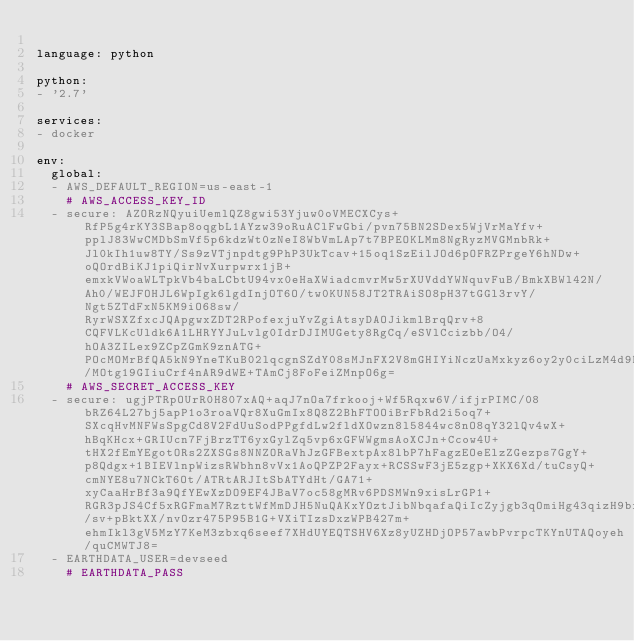Convert code to text. <code><loc_0><loc_0><loc_500><loc_500><_YAML_>
language: python

python:
- '2.7'

services:
- docker

env:
  global:
  - AWS_DEFAULT_REGION=us-east-1
    # AWS_ACCESS_KEY_ID
  - secure: AZORzNQyuiUemlQZ8gwi53Yjuw0oVMECXCys+RfP5g4rKY3SBap8oqgbL1AYzw39oRuAClFwGbi/pvn75BN2SDex5WjVrMaYfv+pplJ83WwCMDbSmVf5p6kdzWt0zNeI8WbVmLAp7t7BPEOKLMm8NgRyzMVGMnbRk+Jl0kIh1uw8TY/Ss9zVTjnpdtg9PhP3UkTcav+15oq1SzEilJOd6pOFRZPrgeY6hNDw+oQOrdBiKJ1piQirNvXurpwrx1jB+emxkVWoaWLTpkVb4baLCbtU94vx0eHaXWiadcmvrMw5rXUVddYWNquvFuB/BmkXBWl42N/Ah0/WEJFOHJL6WpIgk6lgdInjOT6O/tw0KUN58JT2TRAiSO8pH37tGGl3rvY/Ngt5ZTdFxN5KM9iO68sw/RyrWSXZfxcJQApgwxZDT2RPofexjuYvZgiAtsyDAOJikmlBrqQrv+8CQFVLKcUldk6A1LHRYYJuLvlg0IdrDJIMUGety8RgCq/eSVlCcizbb/O4/hOA3ZILex9ZCpZGmK9znATG+POcMOMrBfQA5kN9YneTKuB02lqcgnSZdY08sMJnFX2V8mGHIYiNczUaMxkyz6oy2y0ciLzM4d9BQjd8SFmJNHmXTSDc4AU4vW/MOtg19GIiuCrf4nAR9dWE+TAmCj8FoFeiZMnpO6g=
    # AWS_SECRET_ACCESS_KEY
  - secure: ugjPTRpOUrR0H807xAQ+aqJ7nOa7frkooj+Wf5Rqxw6V/ifjrPIMC/08bRZ64L27bj5apP1o3roaVQr8XuGmIx8Q8Z2BhFTOOiBrFbRd2i5oq7+SXcqHvMNFWsSpgCd8V2FdUuSodPPgfdLw2fldXOwzn8l5844wc8nO8qY32lQv4wX+hBqKHcx+GRIUcn7FjBrzTT6yxGylZq5vp6xGFWWgmsAoXCJn+Ccow4U+tHX2fEmYEgotORs2ZXSGs8NNZORaVhJzGFBextpAx8lbP7hFagzEOeElzZGezps7GgY+p8Qdgx+1BIEVlnpWizsRWbhn8vVx1AoQPZP2Fayx+RCSSwF3jE5zgp+XKX6Xd/tuCsyQ+cmNYE8u7NCkT6Ot/ATRtARJItSbATYdHt/GA71+xyCaaHrBf3a9QfYEwXzDO9EF4JBaV7oc58gMRv6PDSMWn9xisLrGP1+RGR3pJS4Cf5xRGFmaM7RzttWfMmDJH5NuQAKxYOztJibNbqafaQiIcZyjgb3qOmiHg43qizH9bfF8X8zuQCRj8KbOqOHJ6/sv+pBktXX/nvOzr475P95B1G+VXiTIzsDxzWPB427m+ehmIkl3gV5MzY7KeM3zbxq6seef7XHdUYEQTSHV6Xz8yUZHDjOP57awbPvrpcTKYnUTAQoyeh/quCMWTJ8=
  - EARTHDATA_USER=devseed
    # EARTHDATA_PASS</code> 